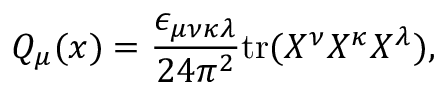<formula> <loc_0><loc_0><loc_500><loc_500>Q _ { \mu } ( x ) = \frac { \epsilon _ { \mu \nu \kappa \lambda } } { 2 4 \pi ^ { 2 } } t r ( X ^ { \nu } X ^ { \kappa } X ^ { \lambda } ) ,</formula> 